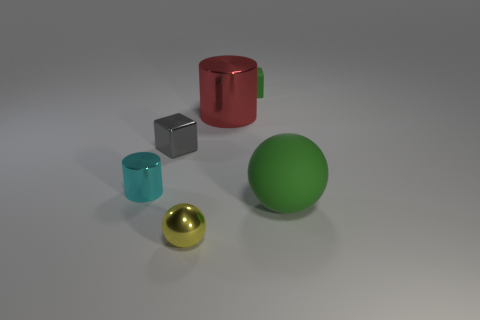How many other things are there of the same material as the tiny gray thing?
Give a very brief answer. 3. There is a big thing behind the small cyan object; does it have the same shape as the tiny gray thing?
Offer a very short reply. No. Are any big spheres visible?
Give a very brief answer. Yes. Is there any other thing that has the same shape as the tiny green rubber thing?
Your answer should be compact. Yes. Is the number of metal objects right of the small metallic ball greater than the number of rubber cylinders?
Provide a short and direct response. Yes. There is a small gray metal block; are there any yellow metallic balls on the right side of it?
Your answer should be compact. Yes. Do the yellow metallic thing and the gray shiny thing have the same size?
Your answer should be very brief. Yes. What size is the yellow metal object that is the same shape as the big green rubber thing?
Your answer should be very brief. Small. Are there any other things that are the same size as the yellow sphere?
Your answer should be very brief. Yes. What material is the tiny block that is in front of the rubber object on the left side of the green ball?
Your response must be concise. Metal. 